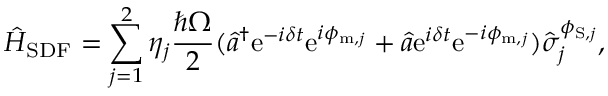<formula> <loc_0><loc_0><loc_500><loc_500>\hat { H } _ { S D F } = \sum _ { j = 1 } ^ { 2 } \eta _ { j } \frac { \hbar { \Omega } } { 2 } ( \hat { a } ^ { \dagger } e ^ { - i \delta t } e ^ { i \phi _ { m , j } } + \hat { a } e ^ { i \delta t } e ^ { - i \phi _ { m , j } } ) \hat { \sigma } _ { j } ^ { \phi _ { S , j } } ,</formula> 